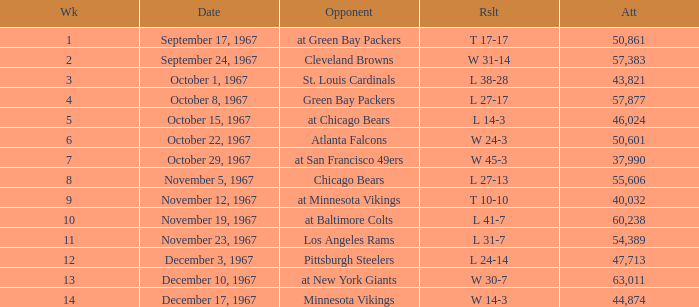How many weeks have a Result of t 10-10? 1.0. 